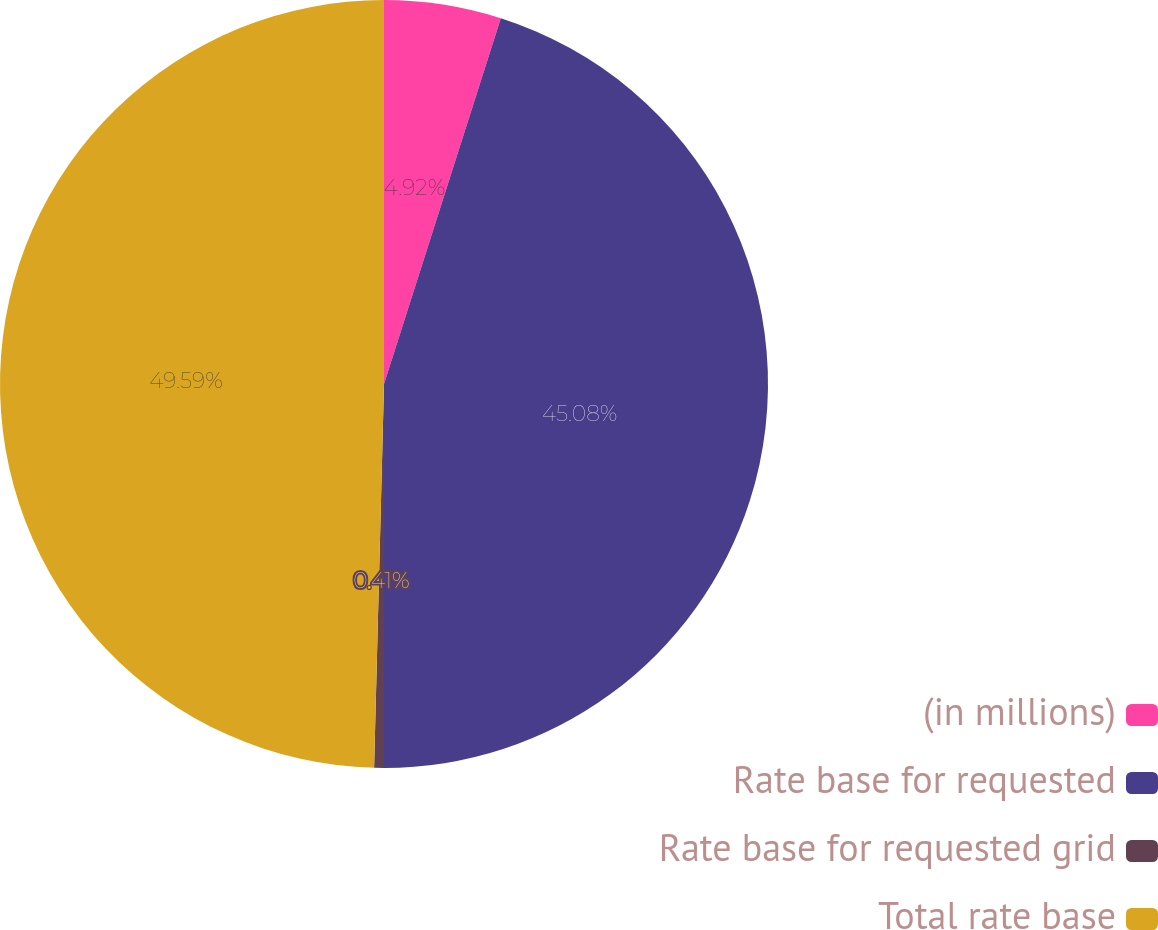<chart> <loc_0><loc_0><loc_500><loc_500><pie_chart><fcel>(in millions)<fcel>Rate base for requested<fcel>Rate base for requested grid<fcel>Total rate base<nl><fcel>4.92%<fcel>45.08%<fcel>0.41%<fcel>49.59%<nl></chart> 